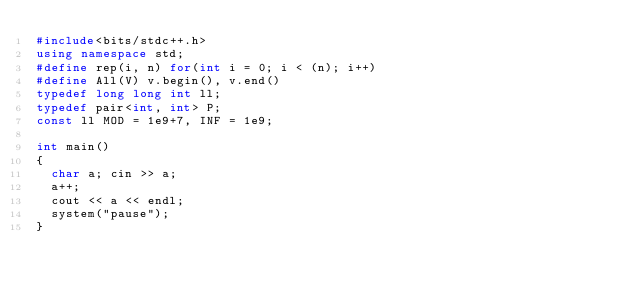Convert code to text. <code><loc_0><loc_0><loc_500><loc_500><_C++_>#include<bits/stdc++.h>
using namespace std;
#define rep(i, n) for(int i = 0; i < (n); i++)
#define All(V) v.begin(), v.end()
typedef long long int ll;
typedef pair<int, int> P;
const ll MOD = 1e9+7, INF = 1e9;

int main() 
{
  char a; cin >> a;
  a++;
  cout << a << endl;
  system("pause");
}</code> 